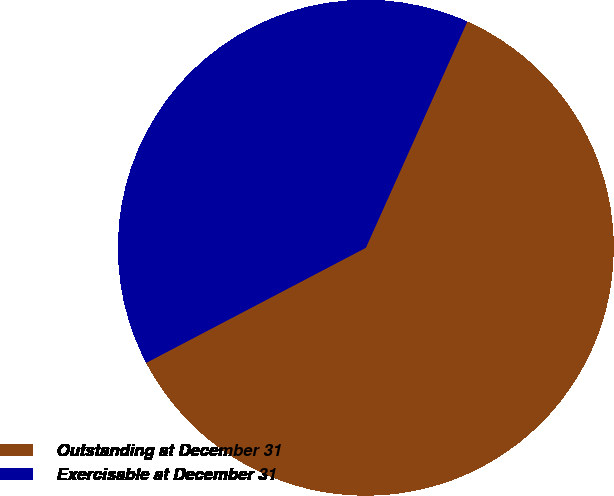<chart> <loc_0><loc_0><loc_500><loc_500><pie_chart><fcel>Outstanding at December 31<fcel>Exercisable at December 31<nl><fcel>60.61%<fcel>39.39%<nl></chart> 